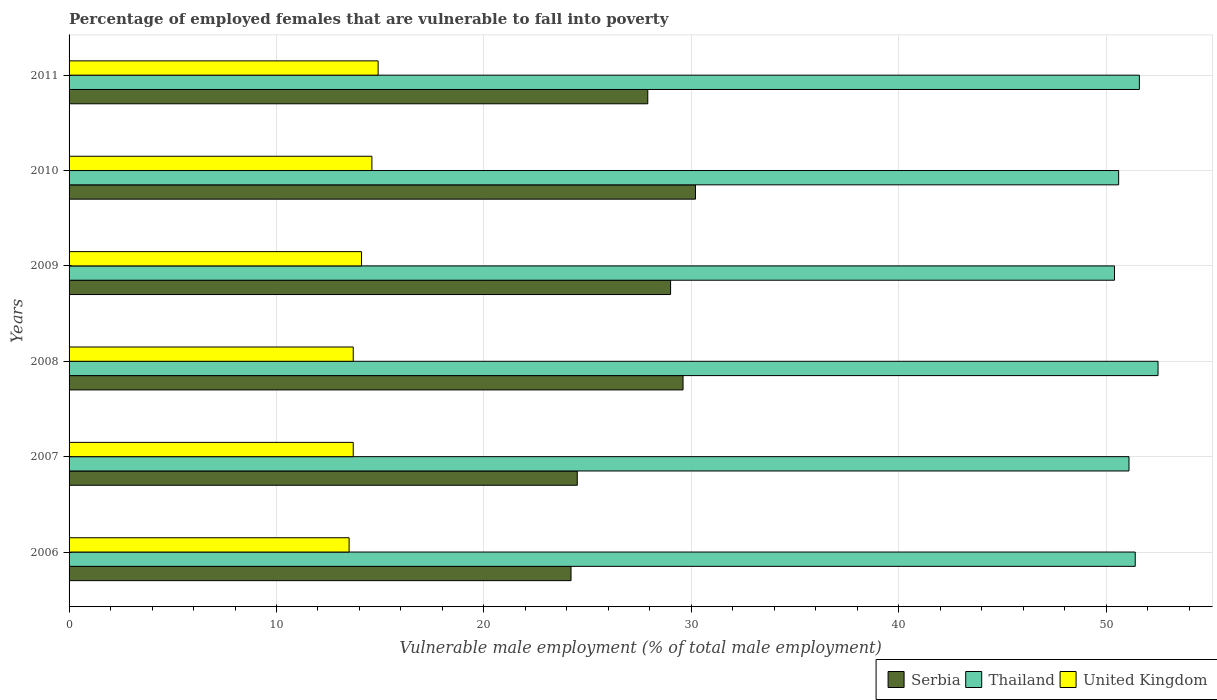Are the number of bars on each tick of the Y-axis equal?
Your answer should be compact. Yes. What is the percentage of employed females who are vulnerable to fall into poverty in United Kingdom in 2008?
Your response must be concise. 13.7. Across all years, what is the maximum percentage of employed females who are vulnerable to fall into poverty in Thailand?
Give a very brief answer. 52.5. What is the total percentage of employed females who are vulnerable to fall into poverty in Serbia in the graph?
Provide a short and direct response. 165.4. What is the difference between the percentage of employed females who are vulnerable to fall into poverty in Serbia in 2006 and that in 2009?
Make the answer very short. -4.8. What is the difference between the percentage of employed females who are vulnerable to fall into poverty in Thailand in 2006 and the percentage of employed females who are vulnerable to fall into poverty in Serbia in 2008?
Ensure brevity in your answer.  21.8. What is the average percentage of employed females who are vulnerable to fall into poverty in Thailand per year?
Give a very brief answer. 51.27. In the year 2008, what is the difference between the percentage of employed females who are vulnerable to fall into poverty in United Kingdom and percentage of employed females who are vulnerable to fall into poverty in Serbia?
Provide a succinct answer. -15.9. What is the ratio of the percentage of employed females who are vulnerable to fall into poverty in United Kingdom in 2006 to that in 2010?
Offer a terse response. 0.92. Is the percentage of employed females who are vulnerable to fall into poverty in United Kingdom in 2008 less than that in 2009?
Your answer should be very brief. Yes. Is the difference between the percentage of employed females who are vulnerable to fall into poverty in United Kingdom in 2008 and 2010 greater than the difference between the percentage of employed females who are vulnerable to fall into poverty in Serbia in 2008 and 2010?
Provide a short and direct response. No. What is the difference between the highest and the second highest percentage of employed females who are vulnerable to fall into poverty in United Kingdom?
Your response must be concise. 0.3. What is the difference between the highest and the lowest percentage of employed females who are vulnerable to fall into poverty in Thailand?
Provide a succinct answer. 2.1. In how many years, is the percentage of employed females who are vulnerable to fall into poverty in Serbia greater than the average percentage of employed females who are vulnerable to fall into poverty in Serbia taken over all years?
Give a very brief answer. 4. What does the 3rd bar from the top in 2008 represents?
Keep it short and to the point. Serbia. Is it the case that in every year, the sum of the percentage of employed females who are vulnerable to fall into poverty in United Kingdom and percentage of employed females who are vulnerable to fall into poverty in Serbia is greater than the percentage of employed females who are vulnerable to fall into poverty in Thailand?
Ensure brevity in your answer.  No. Are all the bars in the graph horizontal?
Your answer should be compact. Yes. What is the difference between two consecutive major ticks on the X-axis?
Make the answer very short. 10. Are the values on the major ticks of X-axis written in scientific E-notation?
Offer a terse response. No. Does the graph contain any zero values?
Make the answer very short. No. How are the legend labels stacked?
Offer a terse response. Horizontal. What is the title of the graph?
Give a very brief answer. Percentage of employed females that are vulnerable to fall into poverty. Does "Trinidad and Tobago" appear as one of the legend labels in the graph?
Your answer should be compact. No. What is the label or title of the X-axis?
Ensure brevity in your answer.  Vulnerable male employment (% of total male employment). What is the label or title of the Y-axis?
Your answer should be compact. Years. What is the Vulnerable male employment (% of total male employment) in Serbia in 2006?
Your response must be concise. 24.2. What is the Vulnerable male employment (% of total male employment) in Thailand in 2006?
Provide a succinct answer. 51.4. What is the Vulnerable male employment (% of total male employment) in Serbia in 2007?
Give a very brief answer. 24.5. What is the Vulnerable male employment (% of total male employment) of Thailand in 2007?
Ensure brevity in your answer.  51.1. What is the Vulnerable male employment (% of total male employment) in United Kingdom in 2007?
Give a very brief answer. 13.7. What is the Vulnerable male employment (% of total male employment) in Serbia in 2008?
Keep it short and to the point. 29.6. What is the Vulnerable male employment (% of total male employment) in Thailand in 2008?
Keep it short and to the point. 52.5. What is the Vulnerable male employment (% of total male employment) in United Kingdom in 2008?
Make the answer very short. 13.7. What is the Vulnerable male employment (% of total male employment) of Serbia in 2009?
Keep it short and to the point. 29. What is the Vulnerable male employment (% of total male employment) in Thailand in 2009?
Your response must be concise. 50.4. What is the Vulnerable male employment (% of total male employment) of United Kingdom in 2009?
Ensure brevity in your answer.  14.1. What is the Vulnerable male employment (% of total male employment) of Serbia in 2010?
Your answer should be very brief. 30.2. What is the Vulnerable male employment (% of total male employment) in Thailand in 2010?
Offer a terse response. 50.6. What is the Vulnerable male employment (% of total male employment) in United Kingdom in 2010?
Provide a short and direct response. 14.6. What is the Vulnerable male employment (% of total male employment) in Serbia in 2011?
Give a very brief answer. 27.9. What is the Vulnerable male employment (% of total male employment) of Thailand in 2011?
Provide a succinct answer. 51.6. What is the Vulnerable male employment (% of total male employment) in United Kingdom in 2011?
Offer a terse response. 14.9. Across all years, what is the maximum Vulnerable male employment (% of total male employment) of Serbia?
Your response must be concise. 30.2. Across all years, what is the maximum Vulnerable male employment (% of total male employment) of Thailand?
Your answer should be very brief. 52.5. Across all years, what is the maximum Vulnerable male employment (% of total male employment) of United Kingdom?
Offer a very short reply. 14.9. Across all years, what is the minimum Vulnerable male employment (% of total male employment) of Serbia?
Your answer should be compact. 24.2. Across all years, what is the minimum Vulnerable male employment (% of total male employment) in Thailand?
Provide a short and direct response. 50.4. Across all years, what is the minimum Vulnerable male employment (% of total male employment) of United Kingdom?
Offer a terse response. 13.5. What is the total Vulnerable male employment (% of total male employment) of Serbia in the graph?
Ensure brevity in your answer.  165.4. What is the total Vulnerable male employment (% of total male employment) of Thailand in the graph?
Provide a succinct answer. 307.6. What is the total Vulnerable male employment (% of total male employment) of United Kingdom in the graph?
Give a very brief answer. 84.5. What is the difference between the Vulnerable male employment (% of total male employment) of Serbia in 2006 and that in 2007?
Provide a short and direct response. -0.3. What is the difference between the Vulnerable male employment (% of total male employment) of United Kingdom in 2006 and that in 2007?
Give a very brief answer. -0.2. What is the difference between the Vulnerable male employment (% of total male employment) in United Kingdom in 2006 and that in 2008?
Your response must be concise. -0.2. What is the difference between the Vulnerable male employment (% of total male employment) of Thailand in 2006 and that in 2009?
Give a very brief answer. 1. What is the difference between the Vulnerable male employment (% of total male employment) in United Kingdom in 2006 and that in 2009?
Keep it short and to the point. -0.6. What is the difference between the Vulnerable male employment (% of total male employment) of Serbia in 2006 and that in 2010?
Provide a short and direct response. -6. What is the difference between the Vulnerable male employment (% of total male employment) in United Kingdom in 2006 and that in 2010?
Make the answer very short. -1.1. What is the difference between the Vulnerable male employment (% of total male employment) in Thailand in 2007 and that in 2008?
Ensure brevity in your answer.  -1.4. What is the difference between the Vulnerable male employment (% of total male employment) of United Kingdom in 2007 and that in 2008?
Your answer should be compact. 0. What is the difference between the Vulnerable male employment (% of total male employment) of Serbia in 2007 and that in 2009?
Offer a very short reply. -4.5. What is the difference between the Vulnerable male employment (% of total male employment) of Thailand in 2007 and that in 2009?
Make the answer very short. 0.7. What is the difference between the Vulnerable male employment (% of total male employment) of United Kingdom in 2007 and that in 2009?
Ensure brevity in your answer.  -0.4. What is the difference between the Vulnerable male employment (% of total male employment) in Serbia in 2007 and that in 2010?
Keep it short and to the point. -5.7. What is the difference between the Vulnerable male employment (% of total male employment) of Thailand in 2007 and that in 2010?
Your answer should be very brief. 0.5. What is the difference between the Vulnerable male employment (% of total male employment) of Serbia in 2007 and that in 2011?
Your response must be concise. -3.4. What is the difference between the Vulnerable male employment (% of total male employment) in United Kingdom in 2007 and that in 2011?
Provide a succinct answer. -1.2. What is the difference between the Vulnerable male employment (% of total male employment) of Serbia in 2008 and that in 2009?
Make the answer very short. 0.6. What is the difference between the Vulnerable male employment (% of total male employment) of Thailand in 2008 and that in 2009?
Your response must be concise. 2.1. What is the difference between the Vulnerable male employment (% of total male employment) in United Kingdom in 2008 and that in 2009?
Provide a succinct answer. -0.4. What is the difference between the Vulnerable male employment (% of total male employment) of Thailand in 2008 and that in 2011?
Ensure brevity in your answer.  0.9. What is the difference between the Vulnerable male employment (% of total male employment) of United Kingdom in 2008 and that in 2011?
Your response must be concise. -1.2. What is the difference between the Vulnerable male employment (% of total male employment) in Serbia in 2009 and that in 2010?
Make the answer very short. -1.2. What is the difference between the Vulnerable male employment (% of total male employment) of Serbia in 2009 and that in 2011?
Ensure brevity in your answer.  1.1. What is the difference between the Vulnerable male employment (% of total male employment) of United Kingdom in 2009 and that in 2011?
Provide a short and direct response. -0.8. What is the difference between the Vulnerable male employment (% of total male employment) of Thailand in 2010 and that in 2011?
Keep it short and to the point. -1. What is the difference between the Vulnerable male employment (% of total male employment) in Serbia in 2006 and the Vulnerable male employment (% of total male employment) in Thailand in 2007?
Your response must be concise. -26.9. What is the difference between the Vulnerable male employment (% of total male employment) of Thailand in 2006 and the Vulnerable male employment (% of total male employment) of United Kingdom in 2007?
Make the answer very short. 37.7. What is the difference between the Vulnerable male employment (% of total male employment) of Serbia in 2006 and the Vulnerable male employment (% of total male employment) of Thailand in 2008?
Your answer should be very brief. -28.3. What is the difference between the Vulnerable male employment (% of total male employment) of Serbia in 2006 and the Vulnerable male employment (% of total male employment) of United Kingdom in 2008?
Offer a terse response. 10.5. What is the difference between the Vulnerable male employment (% of total male employment) of Thailand in 2006 and the Vulnerable male employment (% of total male employment) of United Kingdom in 2008?
Your answer should be very brief. 37.7. What is the difference between the Vulnerable male employment (% of total male employment) in Serbia in 2006 and the Vulnerable male employment (% of total male employment) in Thailand in 2009?
Offer a very short reply. -26.2. What is the difference between the Vulnerable male employment (% of total male employment) in Thailand in 2006 and the Vulnerable male employment (% of total male employment) in United Kingdom in 2009?
Offer a terse response. 37.3. What is the difference between the Vulnerable male employment (% of total male employment) of Serbia in 2006 and the Vulnerable male employment (% of total male employment) of Thailand in 2010?
Give a very brief answer. -26.4. What is the difference between the Vulnerable male employment (% of total male employment) in Thailand in 2006 and the Vulnerable male employment (% of total male employment) in United Kingdom in 2010?
Your answer should be compact. 36.8. What is the difference between the Vulnerable male employment (% of total male employment) in Serbia in 2006 and the Vulnerable male employment (% of total male employment) in Thailand in 2011?
Your answer should be very brief. -27.4. What is the difference between the Vulnerable male employment (% of total male employment) of Thailand in 2006 and the Vulnerable male employment (% of total male employment) of United Kingdom in 2011?
Offer a very short reply. 36.5. What is the difference between the Vulnerable male employment (% of total male employment) of Thailand in 2007 and the Vulnerable male employment (% of total male employment) of United Kingdom in 2008?
Provide a short and direct response. 37.4. What is the difference between the Vulnerable male employment (% of total male employment) in Serbia in 2007 and the Vulnerable male employment (% of total male employment) in Thailand in 2009?
Ensure brevity in your answer.  -25.9. What is the difference between the Vulnerable male employment (% of total male employment) in Serbia in 2007 and the Vulnerable male employment (% of total male employment) in United Kingdom in 2009?
Your response must be concise. 10.4. What is the difference between the Vulnerable male employment (% of total male employment) of Serbia in 2007 and the Vulnerable male employment (% of total male employment) of Thailand in 2010?
Offer a terse response. -26.1. What is the difference between the Vulnerable male employment (% of total male employment) of Thailand in 2007 and the Vulnerable male employment (% of total male employment) of United Kingdom in 2010?
Give a very brief answer. 36.5. What is the difference between the Vulnerable male employment (% of total male employment) of Serbia in 2007 and the Vulnerable male employment (% of total male employment) of Thailand in 2011?
Provide a succinct answer. -27.1. What is the difference between the Vulnerable male employment (% of total male employment) of Thailand in 2007 and the Vulnerable male employment (% of total male employment) of United Kingdom in 2011?
Make the answer very short. 36.2. What is the difference between the Vulnerable male employment (% of total male employment) of Serbia in 2008 and the Vulnerable male employment (% of total male employment) of Thailand in 2009?
Provide a succinct answer. -20.8. What is the difference between the Vulnerable male employment (% of total male employment) in Thailand in 2008 and the Vulnerable male employment (% of total male employment) in United Kingdom in 2009?
Ensure brevity in your answer.  38.4. What is the difference between the Vulnerable male employment (% of total male employment) of Serbia in 2008 and the Vulnerable male employment (% of total male employment) of United Kingdom in 2010?
Your answer should be compact. 15. What is the difference between the Vulnerable male employment (% of total male employment) of Thailand in 2008 and the Vulnerable male employment (% of total male employment) of United Kingdom in 2010?
Offer a very short reply. 37.9. What is the difference between the Vulnerable male employment (% of total male employment) of Thailand in 2008 and the Vulnerable male employment (% of total male employment) of United Kingdom in 2011?
Keep it short and to the point. 37.6. What is the difference between the Vulnerable male employment (% of total male employment) of Serbia in 2009 and the Vulnerable male employment (% of total male employment) of Thailand in 2010?
Your answer should be very brief. -21.6. What is the difference between the Vulnerable male employment (% of total male employment) in Thailand in 2009 and the Vulnerable male employment (% of total male employment) in United Kingdom in 2010?
Give a very brief answer. 35.8. What is the difference between the Vulnerable male employment (% of total male employment) of Serbia in 2009 and the Vulnerable male employment (% of total male employment) of Thailand in 2011?
Your response must be concise. -22.6. What is the difference between the Vulnerable male employment (% of total male employment) of Serbia in 2009 and the Vulnerable male employment (% of total male employment) of United Kingdom in 2011?
Provide a short and direct response. 14.1. What is the difference between the Vulnerable male employment (% of total male employment) in Thailand in 2009 and the Vulnerable male employment (% of total male employment) in United Kingdom in 2011?
Ensure brevity in your answer.  35.5. What is the difference between the Vulnerable male employment (% of total male employment) of Serbia in 2010 and the Vulnerable male employment (% of total male employment) of Thailand in 2011?
Your answer should be compact. -21.4. What is the difference between the Vulnerable male employment (% of total male employment) of Serbia in 2010 and the Vulnerable male employment (% of total male employment) of United Kingdom in 2011?
Offer a very short reply. 15.3. What is the difference between the Vulnerable male employment (% of total male employment) of Thailand in 2010 and the Vulnerable male employment (% of total male employment) of United Kingdom in 2011?
Your response must be concise. 35.7. What is the average Vulnerable male employment (% of total male employment) in Serbia per year?
Provide a succinct answer. 27.57. What is the average Vulnerable male employment (% of total male employment) in Thailand per year?
Offer a very short reply. 51.27. What is the average Vulnerable male employment (% of total male employment) in United Kingdom per year?
Your answer should be compact. 14.08. In the year 2006, what is the difference between the Vulnerable male employment (% of total male employment) of Serbia and Vulnerable male employment (% of total male employment) of Thailand?
Give a very brief answer. -27.2. In the year 2006, what is the difference between the Vulnerable male employment (% of total male employment) in Serbia and Vulnerable male employment (% of total male employment) in United Kingdom?
Your answer should be compact. 10.7. In the year 2006, what is the difference between the Vulnerable male employment (% of total male employment) in Thailand and Vulnerable male employment (% of total male employment) in United Kingdom?
Your response must be concise. 37.9. In the year 2007, what is the difference between the Vulnerable male employment (% of total male employment) of Serbia and Vulnerable male employment (% of total male employment) of Thailand?
Provide a succinct answer. -26.6. In the year 2007, what is the difference between the Vulnerable male employment (% of total male employment) of Thailand and Vulnerable male employment (% of total male employment) of United Kingdom?
Provide a short and direct response. 37.4. In the year 2008, what is the difference between the Vulnerable male employment (% of total male employment) in Serbia and Vulnerable male employment (% of total male employment) in Thailand?
Ensure brevity in your answer.  -22.9. In the year 2008, what is the difference between the Vulnerable male employment (% of total male employment) of Serbia and Vulnerable male employment (% of total male employment) of United Kingdom?
Ensure brevity in your answer.  15.9. In the year 2008, what is the difference between the Vulnerable male employment (% of total male employment) in Thailand and Vulnerable male employment (% of total male employment) in United Kingdom?
Your answer should be very brief. 38.8. In the year 2009, what is the difference between the Vulnerable male employment (% of total male employment) in Serbia and Vulnerable male employment (% of total male employment) in Thailand?
Ensure brevity in your answer.  -21.4. In the year 2009, what is the difference between the Vulnerable male employment (% of total male employment) of Serbia and Vulnerable male employment (% of total male employment) of United Kingdom?
Keep it short and to the point. 14.9. In the year 2009, what is the difference between the Vulnerable male employment (% of total male employment) in Thailand and Vulnerable male employment (% of total male employment) in United Kingdom?
Your answer should be compact. 36.3. In the year 2010, what is the difference between the Vulnerable male employment (% of total male employment) in Serbia and Vulnerable male employment (% of total male employment) in Thailand?
Your response must be concise. -20.4. In the year 2010, what is the difference between the Vulnerable male employment (% of total male employment) of Serbia and Vulnerable male employment (% of total male employment) of United Kingdom?
Offer a very short reply. 15.6. In the year 2011, what is the difference between the Vulnerable male employment (% of total male employment) of Serbia and Vulnerable male employment (% of total male employment) of Thailand?
Your answer should be compact. -23.7. In the year 2011, what is the difference between the Vulnerable male employment (% of total male employment) in Thailand and Vulnerable male employment (% of total male employment) in United Kingdom?
Offer a terse response. 36.7. What is the ratio of the Vulnerable male employment (% of total male employment) in Thailand in 2006 to that in 2007?
Keep it short and to the point. 1.01. What is the ratio of the Vulnerable male employment (% of total male employment) of United Kingdom in 2006 to that in 2007?
Your answer should be compact. 0.99. What is the ratio of the Vulnerable male employment (% of total male employment) in Serbia in 2006 to that in 2008?
Ensure brevity in your answer.  0.82. What is the ratio of the Vulnerable male employment (% of total male employment) of Thailand in 2006 to that in 2008?
Offer a terse response. 0.98. What is the ratio of the Vulnerable male employment (% of total male employment) of United Kingdom in 2006 to that in 2008?
Your response must be concise. 0.99. What is the ratio of the Vulnerable male employment (% of total male employment) in Serbia in 2006 to that in 2009?
Provide a succinct answer. 0.83. What is the ratio of the Vulnerable male employment (% of total male employment) in Thailand in 2006 to that in 2009?
Keep it short and to the point. 1.02. What is the ratio of the Vulnerable male employment (% of total male employment) of United Kingdom in 2006 to that in 2009?
Offer a terse response. 0.96. What is the ratio of the Vulnerable male employment (% of total male employment) in Serbia in 2006 to that in 2010?
Your answer should be very brief. 0.8. What is the ratio of the Vulnerable male employment (% of total male employment) in Thailand in 2006 to that in 2010?
Offer a very short reply. 1.02. What is the ratio of the Vulnerable male employment (% of total male employment) of United Kingdom in 2006 to that in 2010?
Your response must be concise. 0.92. What is the ratio of the Vulnerable male employment (% of total male employment) in Serbia in 2006 to that in 2011?
Your answer should be compact. 0.87. What is the ratio of the Vulnerable male employment (% of total male employment) in Thailand in 2006 to that in 2011?
Make the answer very short. 1. What is the ratio of the Vulnerable male employment (% of total male employment) of United Kingdom in 2006 to that in 2011?
Give a very brief answer. 0.91. What is the ratio of the Vulnerable male employment (% of total male employment) of Serbia in 2007 to that in 2008?
Your answer should be compact. 0.83. What is the ratio of the Vulnerable male employment (% of total male employment) of Thailand in 2007 to that in 2008?
Offer a terse response. 0.97. What is the ratio of the Vulnerable male employment (% of total male employment) in United Kingdom in 2007 to that in 2008?
Offer a very short reply. 1. What is the ratio of the Vulnerable male employment (% of total male employment) in Serbia in 2007 to that in 2009?
Your answer should be very brief. 0.84. What is the ratio of the Vulnerable male employment (% of total male employment) in Thailand in 2007 to that in 2009?
Your answer should be very brief. 1.01. What is the ratio of the Vulnerable male employment (% of total male employment) of United Kingdom in 2007 to that in 2009?
Provide a short and direct response. 0.97. What is the ratio of the Vulnerable male employment (% of total male employment) in Serbia in 2007 to that in 2010?
Your answer should be compact. 0.81. What is the ratio of the Vulnerable male employment (% of total male employment) in Thailand in 2007 to that in 2010?
Provide a succinct answer. 1.01. What is the ratio of the Vulnerable male employment (% of total male employment) of United Kingdom in 2007 to that in 2010?
Provide a succinct answer. 0.94. What is the ratio of the Vulnerable male employment (% of total male employment) in Serbia in 2007 to that in 2011?
Ensure brevity in your answer.  0.88. What is the ratio of the Vulnerable male employment (% of total male employment) of Thailand in 2007 to that in 2011?
Offer a very short reply. 0.99. What is the ratio of the Vulnerable male employment (% of total male employment) in United Kingdom in 2007 to that in 2011?
Provide a short and direct response. 0.92. What is the ratio of the Vulnerable male employment (% of total male employment) in Serbia in 2008 to that in 2009?
Keep it short and to the point. 1.02. What is the ratio of the Vulnerable male employment (% of total male employment) of Thailand in 2008 to that in 2009?
Ensure brevity in your answer.  1.04. What is the ratio of the Vulnerable male employment (% of total male employment) in United Kingdom in 2008 to that in 2009?
Offer a terse response. 0.97. What is the ratio of the Vulnerable male employment (% of total male employment) of Serbia in 2008 to that in 2010?
Provide a short and direct response. 0.98. What is the ratio of the Vulnerable male employment (% of total male employment) of Thailand in 2008 to that in 2010?
Give a very brief answer. 1.04. What is the ratio of the Vulnerable male employment (% of total male employment) in United Kingdom in 2008 to that in 2010?
Provide a succinct answer. 0.94. What is the ratio of the Vulnerable male employment (% of total male employment) in Serbia in 2008 to that in 2011?
Provide a short and direct response. 1.06. What is the ratio of the Vulnerable male employment (% of total male employment) of Thailand in 2008 to that in 2011?
Give a very brief answer. 1.02. What is the ratio of the Vulnerable male employment (% of total male employment) of United Kingdom in 2008 to that in 2011?
Make the answer very short. 0.92. What is the ratio of the Vulnerable male employment (% of total male employment) of Serbia in 2009 to that in 2010?
Make the answer very short. 0.96. What is the ratio of the Vulnerable male employment (% of total male employment) in Thailand in 2009 to that in 2010?
Offer a very short reply. 1. What is the ratio of the Vulnerable male employment (% of total male employment) of United Kingdom in 2009 to that in 2010?
Make the answer very short. 0.97. What is the ratio of the Vulnerable male employment (% of total male employment) in Serbia in 2009 to that in 2011?
Provide a succinct answer. 1.04. What is the ratio of the Vulnerable male employment (% of total male employment) in Thailand in 2009 to that in 2011?
Make the answer very short. 0.98. What is the ratio of the Vulnerable male employment (% of total male employment) in United Kingdom in 2009 to that in 2011?
Give a very brief answer. 0.95. What is the ratio of the Vulnerable male employment (% of total male employment) in Serbia in 2010 to that in 2011?
Your answer should be very brief. 1.08. What is the ratio of the Vulnerable male employment (% of total male employment) of Thailand in 2010 to that in 2011?
Provide a short and direct response. 0.98. What is the ratio of the Vulnerable male employment (% of total male employment) in United Kingdom in 2010 to that in 2011?
Offer a very short reply. 0.98. What is the difference between the highest and the second highest Vulnerable male employment (% of total male employment) in Serbia?
Give a very brief answer. 0.6. What is the difference between the highest and the second highest Vulnerable male employment (% of total male employment) of United Kingdom?
Your answer should be very brief. 0.3. What is the difference between the highest and the lowest Vulnerable male employment (% of total male employment) of Serbia?
Your answer should be compact. 6. What is the difference between the highest and the lowest Vulnerable male employment (% of total male employment) in Thailand?
Make the answer very short. 2.1. What is the difference between the highest and the lowest Vulnerable male employment (% of total male employment) in United Kingdom?
Provide a short and direct response. 1.4. 